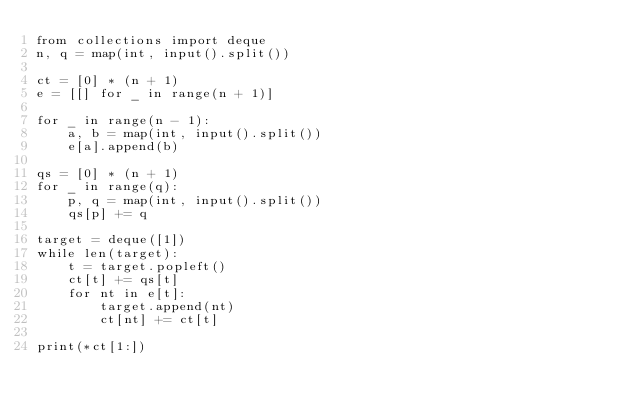<code> <loc_0><loc_0><loc_500><loc_500><_Python_>from collections import deque
n, q = map(int, input().split())

ct = [0] * (n + 1)
e = [[] for _ in range(n + 1)]

for _ in range(n - 1):
    a, b = map(int, input().split())
    e[a].append(b)

qs = [0] * (n + 1)
for _ in range(q):
    p, q = map(int, input().split())
    qs[p] += q

target = deque([1])
while len(target):
    t = target.popleft()
    ct[t] += qs[t]
    for nt in e[t]:
        target.append(nt)
        ct[nt] += ct[t]

print(*ct[1:])
</code> 